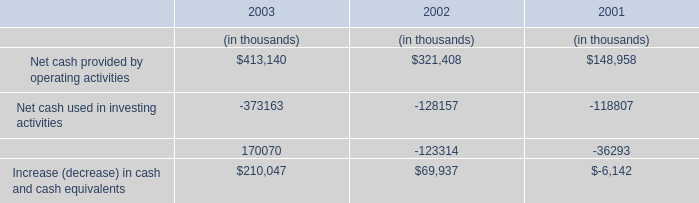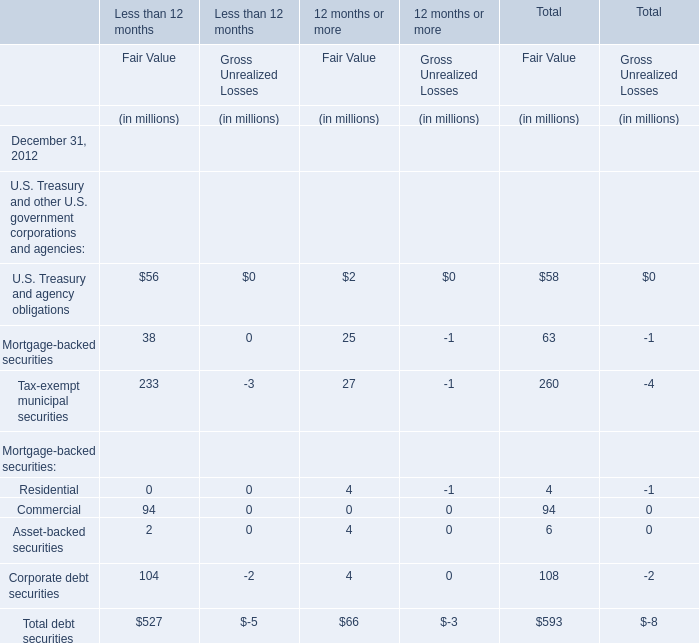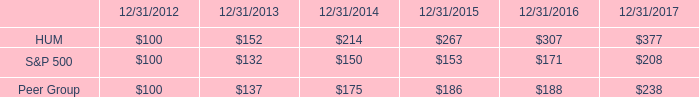How many elements show negative value in 2012 for Fair Value for Total? 
Answer: 0. 